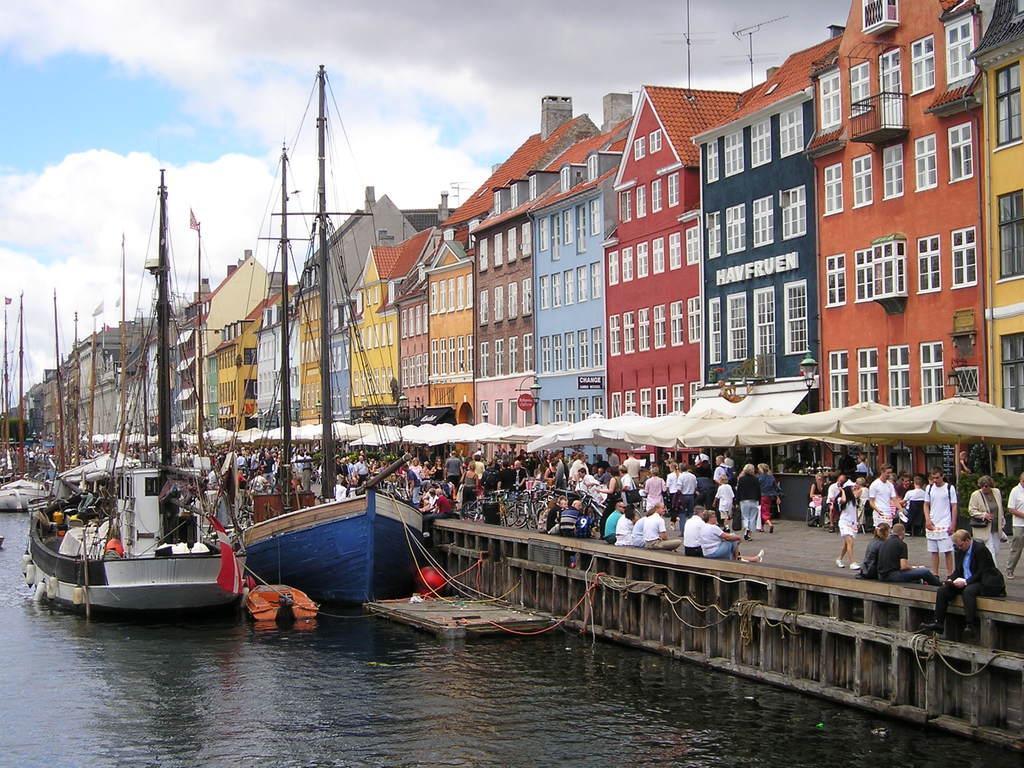Describe this image in one or two sentences. The picture is clicked on a river side where there are beautiful and colorful houses to one side of the image and to the other side there are boats. we also observed many people walking around. There are current poles and cable poles to the left side of the image. 